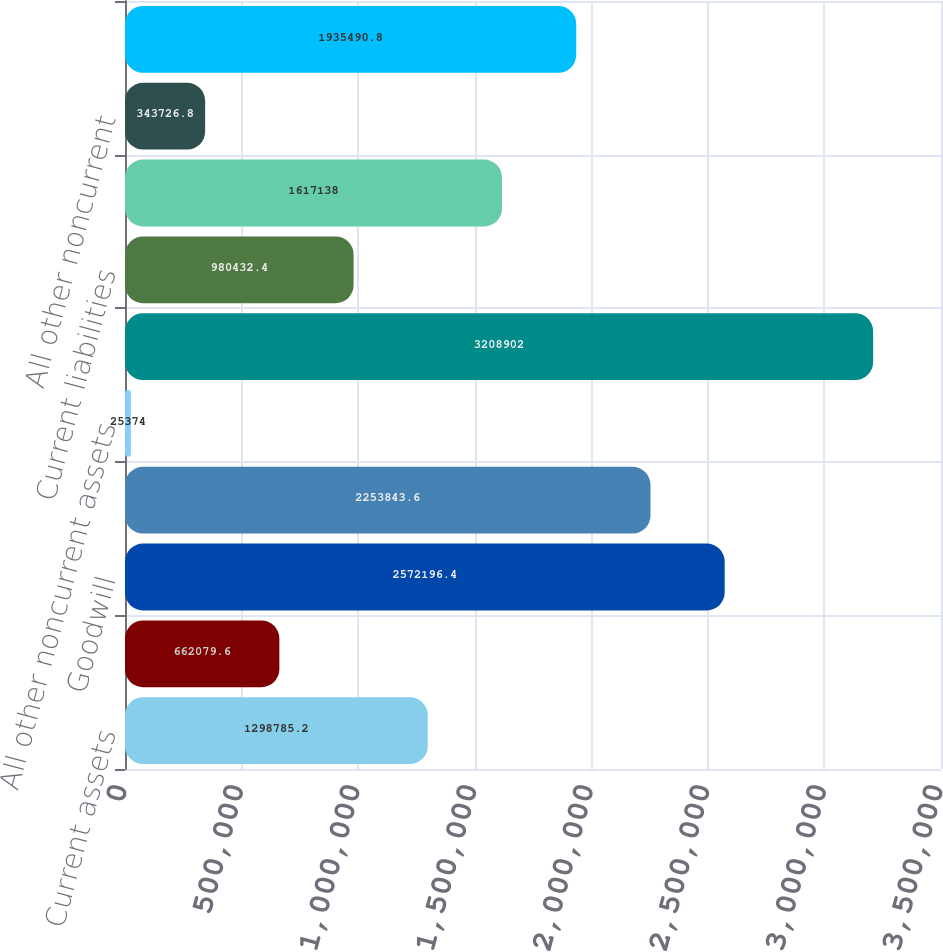<chart> <loc_0><loc_0><loc_500><loc_500><bar_chart><fcel>Current assets<fcel>Net property plant and<fcel>Goodwill<fcel>Other intangibles net of<fcel>All other noncurrent assets<fcel>Assets held for sale<fcel>Current liabilities<fcel>Deferred income taxes<fcel>All other noncurrent<fcel>Liabilities held for sale<nl><fcel>1.29879e+06<fcel>662080<fcel>2.5722e+06<fcel>2.25384e+06<fcel>25374<fcel>3.2089e+06<fcel>980432<fcel>1.61714e+06<fcel>343727<fcel>1.93549e+06<nl></chart> 